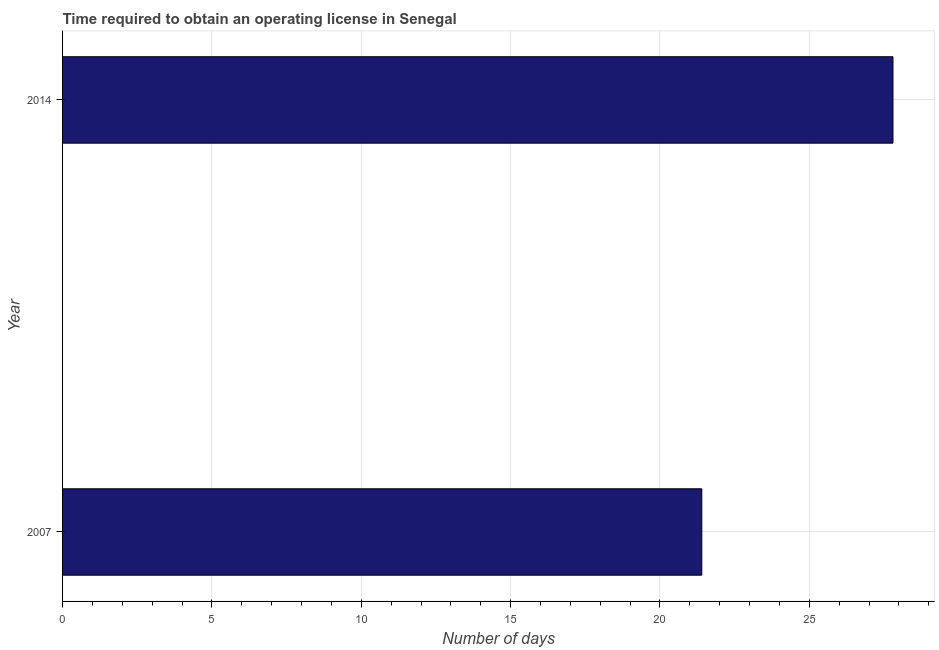What is the title of the graph?
Your response must be concise. Time required to obtain an operating license in Senegal. What is the label or title of the X-axis?
Your answer should be very brief. Number of days. What is the number of days to obtain operating license in 2007?
Give a very brief answer. 21.4. Across all years, what is the maximum number of days to obtain operating license?
Your answer should be compact. 27.8. Across all years, what is the minimum number of days to obtain operating license?
Provide a short and direct response. 21.4. In which year was the number of days to obtain operating license maximum?
Your response must be concise. 2014. In which year was the number of days to obtain operating license minimum?
Your response must be concise. 2007. What is the sum of the number of days to obtain operating license?
Your answer should be compact. 49.2. What is the average number of days to obtain operating license per year?
Keep it short and to the point. 24.6. What is the median number of days to obtain operating license?
Give a very brief answer. 24.6. In how many years, is the number of days to obtain operating license greater than 17 days?
Keep it short and to the point. 2. Do a majority of the years between 2014 and 2007 (inclusive) have number of days to obtain operating license greater than 20 days?
Give a very brief answer. No. What is the ratio of the number of days to obtain operating license in 2007 to that in 2014?
Your answer should be compact. 0.77. Is the number of days to obtain operating license in 2007 less than that in 2014?
Ensure brevity in your answer.  Yes. In how many years, is the number of days to obtain operating license greater than the average number of days to obtain operating license taken over all years?
Offer a very short reply. 1. Are all the bars in the graph horizontal?
Provide a succinct answer. Yes. What is the Number of days of 2007?
Offer a very short reply. 21.4. What is the Number of days of 2014?
Ensure brevity in your answer.  27.8. What is the ratio of the Number of days in 2007 to that in 2014?
Ensure brevity in your answer.  0.77. 